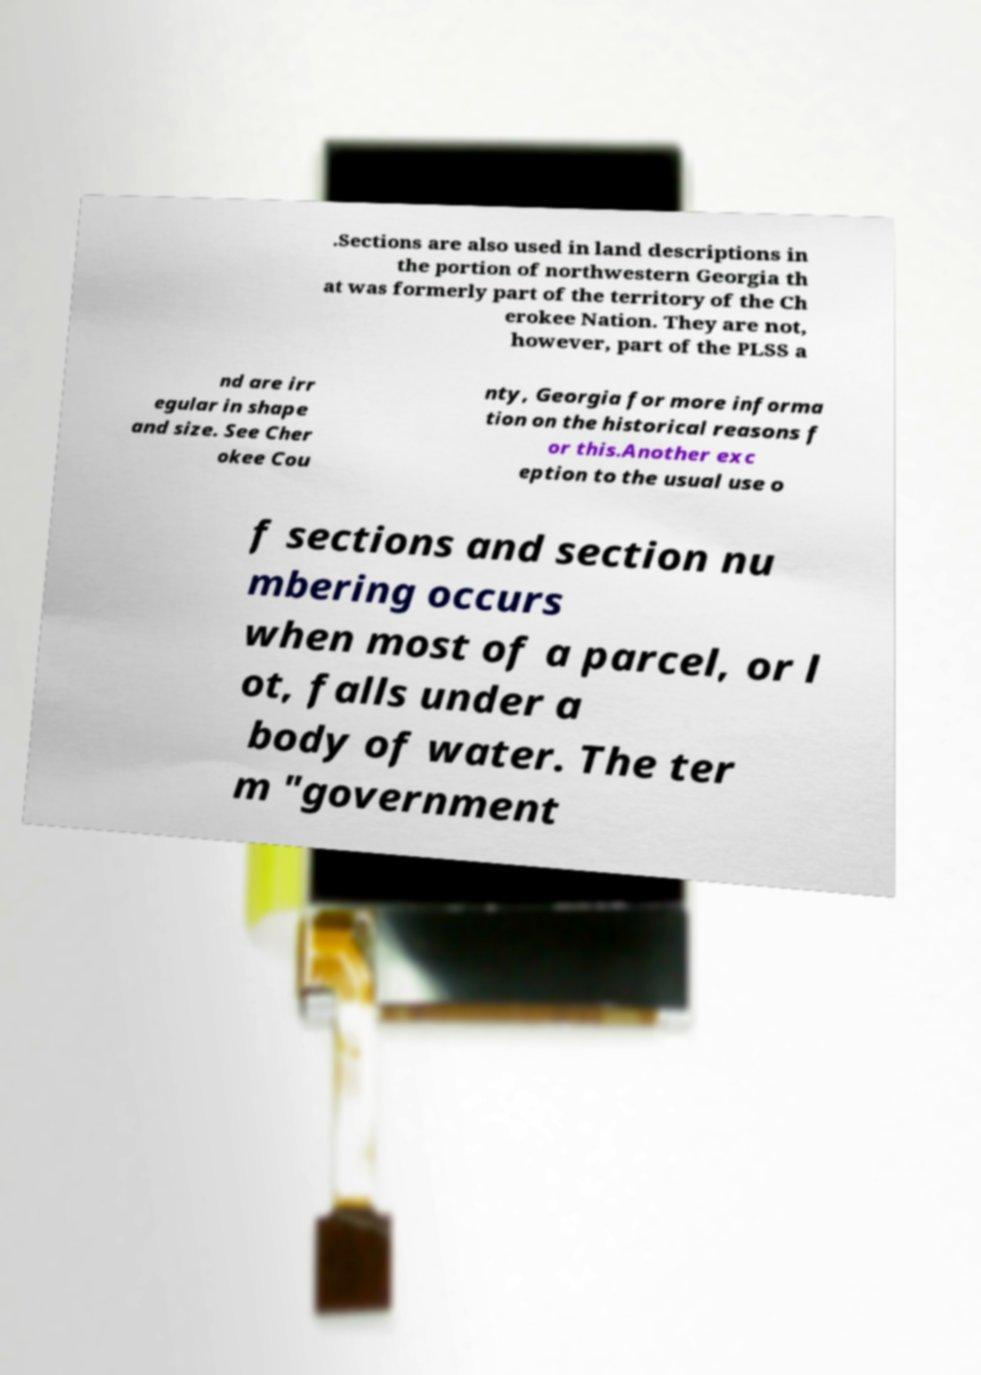I need the written content from this picture converted into text. Can you do that? .Sections are also used in land descriptions in the portion of northwestern Georgia th at was formerly part of the territory of the Ch erokee Nation. They are not, however, part of the PLSS a nd are irr egular in shape and size. See Cher okee Cou nty, Georgia for more informa tion on the historical reasons f or this.Another exc eption to the usual use o f sections and section nu mbering occurs when most of a parcel, or l ot, falls under a body of water. The ter m "government 